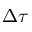<formula> <loc_0><loc_0><loc_500><loc_500>\Delta \tau</formula> 